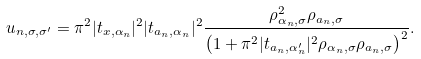Convert formula to latex. <formula><loc_0><loc_0><loc_500><loc_500>u _ { n , \sigma , \sigma ^ { \prime } } = \pi ^ { 2 } | t _ { x , \alpha _ { n } } | ^ { 2 } | t _ { a _ { n } , \alpha _ { n } } | ^ { 2 } \frac { \rho _ { \alpha _ { n } , \sigma } ^ { 2 } \rho _ { a _ { n } , \sigma } } { \left ( 1 + \pi ^ { 2 } | t _ { a _ { n } , \alpha ^ { \prime } _ { n } } | ^ { 2 } \rho _ { \alpha _ { n } , \sigma } \rho _ { a _ { n } , \sigma } \right ) ^ { 2 } } .</formula> 